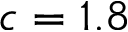Convert formula to latex. <formula><loc_0><loc_0><loc_500><loc_500>c = 1 . 8</formula> 